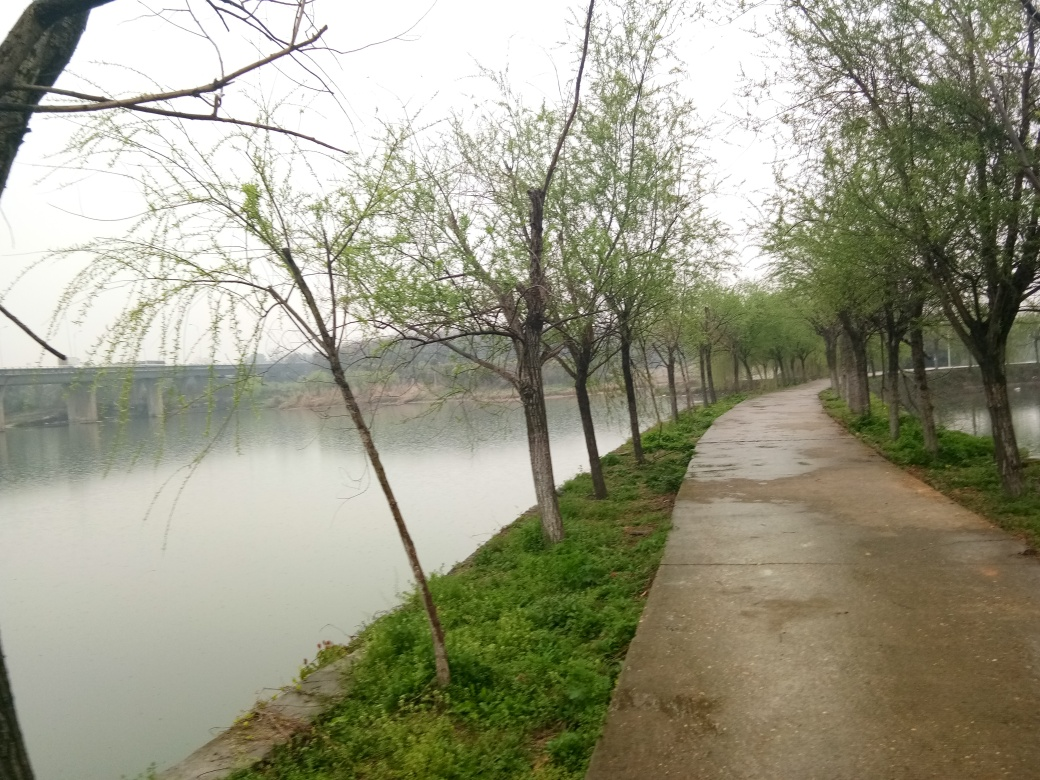What is the overall clarity of the image? The overall clarity of the image is fairly good with some haziness possibly due to atmospheric conditions or camera focus, which provides a soft character to the scene. The image portrays a serene pathway along a river lined with budding trees, suggesting early spring. The composition allows a viewer to appreciate the tranquility of the setting. 